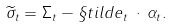Convert formula to latex. <formula><loc_0><loc_0><loc_500><loc_500>\widetilde { \sigma } _ { t } = \Sigma _ { t } - \S t i l d e _ { t } \, \cdot \, \alpha _ { t } .</formula> 